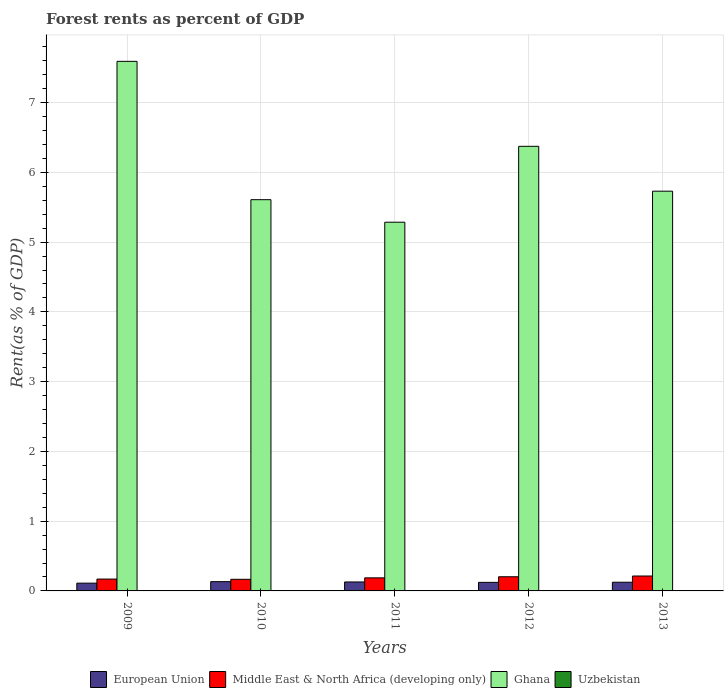How many different coloured bars are there?
Your answer should be very brief. 4. Are the number of bars per tick equal to the number of legend labels?
Make the answer very short. Yes. How many bars are there on the 2nd tick from the right?
Give a very brief answer. 4. What is the label of the 1st group of bars from the left?
Provide a short and direct response. 2009. In how many cases, is the number of bars for a given year not equal to the number of legend labels?
Your answer should be very brief. 0. What is the forest rent in Uzbekistan in 2010?
Your answer should be compact. 0. Across all years, what is the maximum forest rent in Ghana?
Provide a short and direct response. 7.59. Across all years, what is the minimum forest rent in European Union?
Offer a terse response. 0.11. What is the total forest rent in European Union in the graph?
Provide a short and direct response. 0.62. What is the difference between the forest rent in Ghana in 2009 and that in 2010?
Offer a terse response. 1.98. What is the difference between the forest rent in Uzbekistan in 2010 and the forest rent in European Union in 2012?
Provide a short and direct response. -0.12. What is the average forest rent in Uzbekistan per year?
Offer a very short reply. 0. In the year 2012, what is the difference between the forest rent in Uzbekistan and forest rent in Middle East & North Africa (developing only)?
Your answer should be compact. -0.2. In how many years, is the forest rent in Uzbekistan greater than 6.4 %?
Ensure brevity in your answer.  0. What is the ratio of the forest rent in Ghana in 2011 to that in 2012?
Provide a short and direct response. 0.83. Is the forest rent in Uzbekistan in 2010 less than that in 2011?
Your answer should be compact. Yes. Is the difference between the forest rent in Uzbekistan in 2010 and 2013 greater than the difference between the forest rent in Middle East & North Africa (developing only) in 2010 and 2013?
Keep it short and to the point. Yes. What is the difference between the highest and the second highest forest rent in European Union?
Keep it short and to the point. 0. What is the difference between the highest and the lowest forest rent in European Union?
Your answer should be compact. 0.02. In how many years, is the forest rent in Middle East & North Africa (developing only) greater than the average forest rent in Middle East & North Africa (developing only) taken over all years?
Provide a succinct answer. 2. What does the 2nd bar from the left in 2013 represents?
Ensure brevity in your answer.  Middle East & North Africa (developing only). Are all the bars in the graph horizontal?
Provide a succinct answer. No. What is the difference between two consecutive major ticks on the Y-axis?
Provide a succinct answer. 1. Does the graph contain any zero values?
Ensure brevity in your answer.  No. Where does the legend appear in the graph?
Ensure brevity in your answer.  Bottom center. What is the title of the graph?
Provide a succinct answer. Forest rents as percent of GDP. Does "Bhutan" appear as one of the legend labels in the graph?
Ensure brevity in your answer.  No. What is the label or title of the X-axis?
Keep it short and to the point. Years. What is the label or title of the Y-axis?
Give a very brief answer. Rent(as % of GDP). What is the Rent(as % of GDP) of European Union in 2009?
Keep it short and to the point. 0.11. What is the Rent(as % of GDP) in Middle East & North Africa (developing only) in 2009?
Give a very brief answer. 0.17. What is the Rent(as % of GDP) in Ghana in 2009?
Keep it short and to the point. 7.59. What is the Rent(as % of GDP) in Uzbekistan in 2009?
Your response must be concise. 0. What is the Rent(as % of GDP) of European Union in 2010?
Give a very brief answer. 0.13. What is the Rent(as % of GDP) of Middle East & North Africa (developing only) in 2010?
Your answer should be compact. 0.17. What is the Rent(as % of GDP) in Ghana in 2010?
Keep it short and to the point. 5.61. What is the Rent(as % of GDP) of Uzbekistan in 2010?
Offer a very short reply. 0. What is the Rent(as % of GDP) of European Union in 2011?
Offer a terse response. 0.13. What is the Rent(as % of GDP) of Middle East & North Africa (developing only) in 2011?
Your answer should be compact. 0.19. What is the Rent(as % of GDP) of Ghana in 2011?
Offer a terse response. 5.29. What is the Rent(as % of GDP) in Uzbekistan in 2011?
Provide a short and direct response. 0. What is the Rent(as % of GDP) of European Union in 2012?
Provide a short and direct response. 0.12. What is the Rent(as % of GDP) in Middle East & North Africa (developing only) in 2012?
Provide a short and direct response. 0.2. What is the Rent(as % of GDP) in Ghana in 2012?
Ensure brevity in your answer.  6.37. What is the Rent(as % of GDP) of Uzbekistan in 2012?
Provide a succinct answer. 0. What is the Rent(as % of GDP) in European Union in 2013?
Provide a short and direct response. 0.12. What is the Rent(as % of GDP) in Middle East & North Africa (developing only) in 2013?
Make the answer very short. 0.21. What is the Rent(as % of GDP) in Ghana in 2013?
Ensure brevity in your answer.  5.73. What is the Rent(as % of GDP) of Uzbekistan in 2013?
Make the answer very short. 0. Across all years, what is the maximum Rent(as % of GDP) of European Union?
Your answer should be very brief. 0.13. Across all years, what is the maximum Rent(as % of GDP) in Middle East & North Africa (developing only)?
Your answer should be very brief. 0.21. Across all years, what is the maximum Rent(as % of GDP) in Ghana?
Offer a terse response. 7.59. Across all years, what is the maximum Rent(as % of GDP) in Uzbekistan?
Ensure brevity in your answer.  0. Across all years, what is the minimum Rent(as % of GDP) of European Union?
Offer a very short reply. 0.11. Across all years, what is the minimum Rent(as % of GDP) in Middle East & North Africa (developing only)?
Give a very brief answer. 0.17. Across all years, what is the minimum Rent(as % of GDP) in Ghana?
Your answer should be compact. 5.29. Across all years, what is the minimum Rent(as % of GDP) in Uzbekistan?
Provide a short and direct response. 0. What is the total Rent(as % of GDP) of European Union in the graph?
Provide a short and direct response. 0.62. What is the total Rent(as % of GDP) in Middle East & North Africa (developing only) in the graph?
Offer a very short reply. 0.94. What is the total Rent(as % of GDP) of Ghana in the graph?
Give a very brief answer. 30.59. What is the total Rent(as % of GDP) of Uzbekistan in the graph?
Keep it short and to the point. 0.01. What is the difference between the Rent(as % of GDP) in European Union in 2009 and that in 2010?
Offer a very short reply. -0.02. What is the difference between the Rent(as % of GDP) in Middle East & North Africa (developing only) in 2009 and that in 2010?
Keep it short and to the point. 0. What is the difference between the Rent(as % of GDP) of Ghana in 2009 and that in 2010?
Offer a terse response. 1.98. What is the difference between the Rent(as % of GDP) in Uzbekistan in 2009 and that in 2010?
Make the answer very short. 0. What is the difference between the Rent(as % of GDP) of European Union in 2009 and that in 2011?
Your answer should be compact. -0.02. What is the difference between the Rent(as % of GDP) of Middle East & North Africa (developing only) in 2009 and that in 2011?
Your response must be concise. -0.02. What is the difference between the Rent(as % of GDP) in Ghana in 2009 and that in 2011?
Offer a very short reply. 2.31. What is the difference between the Rent(as % of GDP) in Uzbekistan in 2009 and that in 2011?
Your response must be concise. 0. What is the difference between the Rent(as % of GDP) in European Union in 2009 and that in 2012?
Make the answer very short. -0.01. What is the difference between the Rent(as % of GDP) in Middle East & North Africa (developing only) in 2009 and that in 2012?
Your answer should be very brief. -0.03. What is the difference between the Rent(as % of GDP) in Ghana in 2009 and that in 2012?
Make the answer very short. 1.22. What is the difference between the Rent(as % of GDP) in Uzbekistan in 2009 and that in 2012?
Your answer should be compact. 0. What is the difference between the Rent(as % of GDP) of European Union in 2009 and that in 2013?
Provide a succinct answer. -0.01. What is the difference between the Rent(as % of GDP) of Middle East & North Africa (developing only) in 2009 and that in 2013?
Ensure brevity in your answer.  -0.04. What is the difference between the Rent(as % of GDP) of Ghana in 2009 and that in 2013?
Your response must be concise. 1.86. What is the difference between the Rent(as % of GDP) in Uzbekistan in 2009 and that in 2013?
Ensure brevity in your answer.  0. What is the difference between the Rent(as % of GDP) of European Union in 2010 and that in 2011?
Offer a terse response. 0. What is the difference between the Rent(as % of GDP) in Middle East & North Africa (developing only) in 2010 and that in 2011?
Provide a succinct answer. -0.02. What is the difference between the Rent(as % of GDP) of Ghana in 2010 and that in 2011?
Offer a very short reply. 0.32. What is the difference between the Rent(as % of GDP) in Uzbekistan in 2010 and that in 2011?
Give a very brief answer. -0. What is the difference between the Rent(as % of GDP) of European Union in 2010 and that in 2012?
Ensure brevity in your answer.  0.01. What is the difference between the Rent(as % of GDP) of Middle East & North Africa (developing only) in 2010 and that in 2012?
Your answer should be compact. -0.04. What is the difference between the Rent(as % of GDP) in Ghana in 2010 and that in 2012?
Provide a short and direct response. -0.76. What is the difference between the Rent(as % of GDP) in Uzbekistan in 2010 and that in 2012?
Your answer should be compact. -0. What is the difference between the Rent(as % of GDP) of European Union in 2010 and that in 2013?
Your response must be concise. 0.01. What is the difference between the Rent(as % of GDP) of Middle East & North Africa (developing only) in 2010 and that in 2013?
Give a very brief answer. -0.05. What is the difference between the Rent(as % of GDP) of Ghana in 2010 and that in 2013?
Keep it short and to the point. -0.12. What is the difference between the Rent(as % of GDP) in European Union in 2011 and that in 2012?
Provide a succinct answer. 0.01. What is the difference between the Rent(as % of GDP) in Middle East & North Africa (developing only) in 2011 and that in 2012?
Ensure brevity in your answer.  -0.02. What is the difference between the Rent(as % of GDP) of Ghana in 2011 and that in 2012?
Provide a short and direct response. -1.09. What is the difference between the Rent(as % of GDP) in Uzbekistan in 2011 and that in 2012?
Provide a short and direct response. 0. What is the difference between the Rent(as % of GDP) in European Union in 2011 and that in 2013?
Make the answer very short. 0. What is the difference between the Rent(as % of GDP) of Middle East & North Africa (developing only) in 2011 and that in 2013?
Keep it short and to the point. -0.03. What is the difference between the Rent(as % of GDP) in Ghana in 2011 and that in 2013?
Your answer should be very brief. -0.44. What is the difference between the Rent(as % of GDP) in Uzbekistan in 2011 and that in 2013?
Your response must be concise. 0. What is the difference between the Rent(as % of GDP) of European Union in 2012 and that in 2013?
Your response must be concise. -0. What is the difference between the Rent(as % of GDP) of Middle East & North Africa (developing only) in 2012 and that in 2013?
Make the answer very short. -0.01. What is the difference between the Rent(as % of GDP) of Ghana in 2012 and that in 2013?
Your answer should be very brief. 0.64. What is the difference between the Rent(as % of GDP) of Uzbekistan in 2012 and that in 2013?
Offer a very short reply. 0. What is the difference between the Rent(as % of GDP) of European Union in 2009 and the Rent(as % of GDP) of Middle East & North Africa (developing only) in 2010?
Your answer should be compact. -0.06. What is the difference between the Rent(as % of GDP) of European Union in 2009 and the Rent(as % of GDP) of Ghana in 2010?
Give a very brief answer. -5.5. What is the difference between the Rent(as % of GDP) of European Union in 2009 and the Rent(as % of GDP) of Uzbekistan in 2010?
Offer a very short reply. 0.11. What is the difference between the Rent(as % of GDP) in Middle East & North Africa (developing only) in 2009 and the Rent(as % of GDP) in Ghana in 2010?
Provide a short and direct response. -5.44. What is the difference between the Rent(as % of GDP) of Middle East & North Africa (developing only) in 2009 and the Rent(as % of GDP) of Uzbekistan in 2010?
Provide a short and direct response. 0.17. What is the difference between the Rent(as % of GDP) of Ghana in 2009 and the Rent(as % of GDP) of Uzbekistan in 2010?
Your answer should be very brief. 7.59. What is the difference between the Rent(as % of GDP) of European Union in 2009 and the Rent(as % of GDP) of Middle East & North Africa (developing only) in 2011?
Your answer should be very brief. -0.08. What is the difference between the Rent(as % of GDP) in European Union in 2009 and the Rent(as % of GDP) in Ghana in 2011?
Offer a very short reply. -5.17. What is the difference between the Rent(as % of GDP) of European Union in 2009 and the Rent(as % of GDP) of Uzbekistan in 2011?
Your answer should be compact. 0.11. What is the difference between the Rent(as % of GDP) in Middle East & North Africa (developing only) in 2009 and the Rent(as % of GDP) in Ghana in 2011?
Provide a succinct answer. -5.12. What is the difference between the Rent(as % of GDP) of Middle East & North Africa (developing only) in 2009 and the Rent(as % of GDP) of Uzbekistan in 2011?
Make the answer very short. 0.17. What is the difference between the Rent(as % of GDP) of Ghana in 2009 and the Rent(as % of GDP) of Uzbekistan in 2011?
Ensure brevity in your answer.  7.59. What is the difference between the Rent(as % of GDP) in European Union in 2009 and the Rent(as % of GDP) in Middle East & North Africa (developing only) in 2012?
Give a very brief answer. -0.09. What is the difference between the Rent(as % of GDP) in European Union in 2009 and the Rent(as % of GDP) in Ghana in 2012?
Keep it short and to the point. -6.26. What is the difference between the Rent(as % of GDP) in European Union in 2009 and the Rent(as % of GDP) in Uzbekistan in 2012?
Provide a short and direct response. 0.11. What is the difference between the Rent(as % of GDP) of Middle East & North Africa (developing only) in 2009 and the Rent(as % of GDP) of Ghana in 2012?
Your answer should be very brief. -6.2. What is the difference between the Rent(as % of GDP) of Middle East & North Africa (developing only) in 2009 and the Rent(as % of GDP) of Uzbekistan in 2012?
Give a very brief answer. 0.17. What is the difference between the Rent(as % of GDP) in Ghana in 2009 and the Rent(as % of GDP) in Uzbekistan in 2012?
Ensure brevity in your answer.  7.59. What is the difference between the Rent(as % of GDP) of European Union in 2009 and the Rent(as % of GDP) of Middle East & North Africa (developing only) in 2013?
Provide a succinct answer. -0.1. What is the difference between the Rent(as % of GDP) of European Union in 2009 and the Rent(as % of GDP) of Ghana in 2013?
Offer a terse response. -5.62. What is the difference between the Rent(as % of GDP) of European Union in 2009 and the Rent(as % of GDP) of Uzbekistan in 2013?
Your answer should be compact. 0.11. What is the difference between the Rent(as % of GDP) of Middle East & North Africa (developing only) in 2009 and the Rent(as % of GDP) of Ghana in 2013?
Provide a short and direct response. -5.56. What is the difference between the Rent(as % of GDP) in Middle East & North Africa (developing only) in 2009 and the Rent(as % of GDP) in Uzbekistan in 2013?
Your response must be concise. 0.17. What is the difference between the Rent(as % of GDP) of Ghana in 2009 and the Rent(as % of GDP) of Uzbekistan in 2013?
Your response must be concise. 7.59. What is the difference between the Rent(as % of GDP) in European Union in 2010 and the Rent(as % of GDP) in Middle East & North Africa (developing only) in 2011?
Your answer should be compact. -0.05. What is the difference between the Rent(as % of GDP) in European Union in 2010 and the Rent(as % of GDP) in Ghana in 2011?
Make the answer very short. -5.15. What is the difference between the Rent(as % of GDP) in European Union in 2010 and the Rent(as % of GDP) in Uzbekistan in 2011?
Provide a short and direct response. 0.13. What is the difference between the Rent(as % of GDP) in Middle East & North Africa (developing only) in 2010 and the Rent(as % of GDP) in Ghana in 2011?
Your answer should be very brief. -5.12. What is the difference between the Rent(as % of GDP) in Middle East & North Africa (developing only) in 2010 and the Rent(as % of GDP) in Uzbekistan in 2011?
Give a very brief answer. 0.16. What is the difference between the Rent(as % of GDP) of Ghana in 2010 and the Rent(as % of GDP) of Uzbekistan in 2011?
Your answer should be very brief. 5.61. What is the difference between the Rent(as % of GDP) in European Union in 2010 and the Rent(as % of GDP) in Middle East & North Africa (developing only) in 2012?
Your answer should be compact. -0.07. What is the difference between the Rent(as % of GDP) of European Union in 2010 and the Rent(as % of GDP) of Ghana in 2012?
Provide a succinct answer. -6.24. What is the difference between the Rent(as % of GDP) in European Union in 2010 and the Rent(as % of GDP) in Uzbekistan in 2012?
Provide a succinct answer. 0.13. What is the difference between the Rent(as % of GDP) of Middle East & North Africa (developing only) in 2010 and the Rent(as % of GDP) of Ghana in 2012?
Your response must be concise. -6.21. What is the difference between the Rent(as % of GDP) in Middle East & North Africa (developing only) in 2010 and the Rent(as % of GDP) in Uzbekistan in 2012?
Keep it short and to the point. 0.16. What is the difference between the Rent(as % of GDP) in Ghana in 2010 and the Rent(as % of GDP) in Uzbekistan in 2012?
Give a very brief answer. 5.61. What is the difference between the Rent(as % of GDP) of European Union in 2010 and the Rent(as % of GDP) of Middle East & North Africa (developing only) in 2013?
Provide a short and direct response. -0.08. What is the difference between the Rent(as % of GDP) of European Union in 2010 and the Rent(as % of GDP) of Ghana in 2013?
Make the answer very short. -5.6. What is the difference between the Rent(as % of GDP) of European Union in 2010 and the Rent(as % of GDP) of Uzbekistan in 2013?
Your answer should be compact. 0.13. What is the difference between the Rent(as % of GDP) in Middle East & North Africa (developing only) in 2010 and the Rent(as % of GDP) in Ghana in 2013?
Offer a very short reply. -5.56. What is the difference between the Rent(as % of GDP) of Middle East & North Africa (developing only) in 2010 and the Rent(as % of GDP) of Uzbekistan in 2013?
Make the answer very short. 0.16. What is the difference between the Rent(as % of GDP) of Ghana in 2010 and the Rent(as % of GDP) of Uzbekistan in 2013?
Offer a terse response. 5.61. What is the difference between the Rent(as % of GDP) of European Union in 2011 and the Rent(as % of GDP) of Middle East & North Africa (developing only) in 2012?
Ensure brevity in your answer.  -0.07. What is the difference between the Rent(as % of GDP) in European Union in 2011 and the Rent(as % of GDP) in Ghana in 2012?
Your answer should be compact. -6.24. What is the difference between the Rent(as % of GDP) of European Union in 2011 and the Rent(as % of GDP) of Uzbekistan in 2012?
Provide a succinct answer. 0.13. What is the difference between the Rent(as % of GDP) in Middle East & North Africa (developing only) in 2011 and the Rent(as % of GDP) in Ghana in 2012?
Keep it short and to the point. -6.19. What is the difference between the Rent(as % of GDP) of Middle East & North Africa (developing only) in 2011 and the Rent(as % of GDP) of Uzbekistan in 2012?
Provide a short and direct response. 0.18. What is the difference between the Rent(as % of GDP) in Ghana in 2011 and the Rent(as % of GDP) in Uzbekistan in 2012?
Offer a very short reply. 5.28. What is the difference between the Rent(as % of GDP) of European Union in 2011 and the Rent(as % of GDP) of Middle East & North Africa (developing only) in 2013?
Keep it short and to the point. -0.09. What is the difference between the Rent(as % of GDP) in European Union in 2011 and the Rent(as % of GDP) in Ghana in 2013?
Your answer should be compact. -5.6. What is the difference between the Rent(as % of GDP) in European Union in 2011 and the Rent(as % of GDP) in Uzbekistan in 2013?
Offer a terse response. 0.13. What is the difference between the Rent(as % of GDP) in Middle East & North Africa (developing only) in 2011 and the Rent(as % of GDP) in Ghana in 2013?
Make the answer very short. -5.54. What is the difference between the Rent(as % of GDP) in Middle East & North Africa (developing only) in 2011 and the Rent(as % of GDP) in Uzbekistan in 2013?
Your response must be concise. 0.19. What is the difference between the Rent(as % of GDP) in Ghana in 2011 and the Rent(as % of GDP) in Uzbekistan in 2013?
Provide a short and direct response. 5.28. What is the difference between the Rent(as % of GDP) of European Union in 2012 and the Rent(as % of GDP) of Middle East & North Africa (developing only) in 2013?
Your answer should be compact. -0.09. What is the difference between the Rent(as % of GDP) of European Union in 2012 and the Rent(as % of GDP) of Ghana in 2013?
Provide a short and direct response. -5.61. What is the difference between the Rent(as % of GDP) in European Union in 2012 and the Rent(as % of GDP) in Uzbekistan in 2013?
Your answer should be very brief. 0.12. What is the difference between the Rent(as % of GDP) of Middle East & North Africa (developing only) in 2012 and the Rent(as % of GDP) of Ghana in 2013?
Give a very brief answer. -5.53. What is the difference between the Rent(as % of GDP) in Middle East & North Africa (developing only) in 2012 and the Rent(as % of GDP) in Uzbekistan in 2013?
Make the answer very short. 0.2. What is the difference between the Rent(as % of GDP) in Ghana in 2012 and the Rent(as % of GDP) in Uzbekistan in 2013?
Your answer should be compact. 6.37. What is the average Rent(as % of GDP) of European Union per year?
Your answer should be very brief. 0.12. What is the average Rent(as % of GDP) in Middle East & North Africa (developing only) per year?
Ensure brevity in your answer.  0.19. What is the average Rent(as % of GDP) in Ghana per year?
Provide a succinct answer. 6.12. What is the average Rent(as % of GDP) of Uzbekistan per year?
Your answer should be very brief. 0. In the year 2009, what is the difference between the Rent(as % of GDP) in European Union and Rent(as % of GDP) in Middle East & North Africa (developing only)?
Make the answer very short. -0.06. In the year 2009, what is the difference between the Rent(as % of GDP) in European Union and Rent(as % of GDP) in Ghana?
Offer a terse response. -7.48. In the year 2009, what is the difference between the Rent(as % of GDP) of European Union and Rent(as % of GDP) of Uzbekistan?
Offer a very short reply. 0.11. In the year 2009, what is the difference between the Rent(as % of GDP) in Middle East & North Africa (developing only) and Rent(as % of GDP) in Ghana?
Keep it short and to the point. -7.42. In the year 2009, what is the difference between the Rent(as % of GDP) of Middle East & North Africa (developing only) and Rent(as % of GDP) of Uzbekistan?
Your answer should be very brief. 0.17. In the year 2009, what is the difference between the Rent(as % of GDP) in Ghana and Rent(as % of GDP) in Uzbekistan?
Your response must be concise. 7.59. In the year 2010, what is the difference between the Rent(as % of GDP) of European Union and Rent(as % of GDP) of Middle East & North Africa (developing only)?
Make the answer very short. -0.03. In the year 2010, what is the difference between the Rent(as % of GDP) of European Union and Rent(as % of GDP) of Ghana?
Keep it short and to the point. -5.48. In the year 2010, what is the difference between the Rent(as % of GDP) of European Union and Rent(as % of GDP) of Uzbekistan?
Offer a terse response. 0.13. In the year 2010, what is the difference between the Rent(as % of GDP) of Middle East & North Africa (developing only) and Rent(as % of GDP) of Ghana?
Your answer should be very brief. -5.44. In the year 2010, what is the difference between the Rent(as % of GDP) of Middle East & North Africa (developing only) and Rent(as % of GDP) of Uzbekistan?
Your answer should be very brief. 0.16. In the year 2010, what is the difference between the Rent(as % of GDP) in Ghana and Rent(as % of GDP) in Uzbekistan?
Your response must be concise. 5.61. In the year 2011, what is the difference between the Rent(as % of GDP) in European Union and Rent(as % of GDP) in Middle East & North Africa (developing only)?
Your answer should be very brief. -0.06. In the year 2011, what is the difference between the Rent(as % of GDP) in European Union and Rent(as % of GDP) in Ghana?
Make the answer very short. -5.16. In the year 2011, what is the difference between the Rent(as % of GDP) of European Union and Rent(as % of GDP) of Uzbekistan?
Provide a short and direct response. 0.13. In the year 2011, what is the difference between the Rent(as % of GDP) in Middle East & North Africa (developing only) and Rent(as % of GDP) in Ghana?
Give a very brief answer. -5.1. In the year 2011, what is the difference between the Rent(as % of GDP) of Middle East & North Africa (developing only) and Rent(as % of GDP) of Uzbekistan?
Your response must be concise. 0.18. In the year 2011, what is the difference between the Rent(as % of GDP) of Ghana and Rent(as % of GDP) of Uzbekistan?
Provide a succinct answer. 5.28. In the year 2012, what is the difference between the Rent(as % of GDP) in European Union and Rent(as % of GDP) in Middle East & North Africa (developing only)?
Provide a succinct answer. -0.08. In the year 2012, what is the difference between the Rent(as % of GDP) in European Union and Rent(as % of GDP) in Ghana?
Your response must be concise. -6.25. In the year 2012, what is the difference between the Rent(as % of GDP) in European Union and Rent(as % of GDP) in Uzbekistan?
Give a very brief answer. 0.12. In the year 2012, what is the difference between the Rent(as % of GDP) of Middle East & North Africa (developing only) and Rent(as % of GDP) of Ghana?
Give a very brief answer. -6.17. In the year 2012, what is the difference between the Rent(as % of GDP) of Middle East & North Africa (developing only) and Rent(as % of GDP) of Uzbekistan?
Offer a terse response. 0.2. In the year 2012, what is the difference between the Rent(as % of GDP) of Ghana and Rent(as % of GDP) of Uzbekistan?
Your answer should be very brief. 6.37. In the year 2013, what is the difference between the Rent(as % of GDP) in European Union and Rent(as % of GDP) in Middle East & North Africa (developing only)?
Ensure brevity in your answer.  -0.09. In the year 2013, what is the difference between the Rent(as % of GDP) in European Union and Rent(as % of GDP) in Ghana?
Provide a short and direct response. -5.61. In the year 2013, what is the difference between the Rent(as % of GDP) in European Union and Rent(as % of GDP) in Uzbekistan?
Offer a terse response. 0.12. In the year 2013, what is the difference between the Rent(as % of GDP) of Middle East & North Africa (developing only) and Rent(as % of GDP) of Ghana?
Your answer should be compact. -5.52. In the year 2013, what is the difference between the Rent(as % of GDP) in Middle East & North Africa (developing only) and Rent(as % of GDP) in Uzbekistan?
Give a very brief answer. 0.21. In the year 2013, what is the difference between the Rent(as % of GDP) of Ghana and Rent(as % of GDP) of Uzbekistan?
Ensure brevity in your answer.  5.73. What is the ratio of the Rent(as % of GDP) in European Union in 2009 to that in 2010?
Ensure brevity in your answer.  0.84. What is the ratio of the Rent(as % of GDP) in Middle East & North Africa (developing only) in 2009 to that in 2010?
Make the answer very short. 1.02. What is the ratio of the Rent(as % of GDP) in Ghana in 2009 to that in 2010?
Ensure brevity in your answer.  1.35. What is the ratio of the Rent(as % of GDP) of Uzbekistan in 2009 to that in 2010?
Offer a terse response. 1.52. What is the ratio of the Rent(as % of GDP) in European Union in 2009 to that in 2011?
Provide a short and direct response. 0.87. What is the ratio of the Rent(as % of GDP) of Middle East & North Africa (developing only) in 2009 to that in 2011?
Provide a short and direct response. 0.91. What is the ratio of the Rent(as % of GDP) of Ghana in 2009 to that in 2011?
Offer a terse response. 1.44. What is the ratio of the Rent(as % of GDP) of Uzbekistan in 2009 to that in 2011?
Offer a terse response. 1.23. What is the ratio of the Rent(as % of GDP) in European Union in 2009 to that in 2012?
Ensure brevity in your answer.  0.91. What is the ratio of the Rent(as % of GDP) in Middle East & North Africa (developing only) in 2009 to that in 2012?
Your answer should be very brief. 0.84. What is the ratio of the Rent(as % of GDP) of Ghana in 2009 to that in 2012?
Your answer should be very brief. 1.19. What is the ratio of the Rent(as % of GDP) in Uzbekistan in 2009 to that in 2012?
Offer a terse response. 1.44. What is the ratio of the Rent(as % of GDP) of European Union in 2009 to that in 2013?
Offer a terse response. 0.89. What is the ratio of the Rent(as % of GDP) of Middle East & North Africa (developing only) in 2009 to that in 2013?
Offer a terse response. 0.79. What is the ratio of the Rent(as % of GDP) in Ghana in 2009 to that in 2013?
Your answer should be very brief. 1.32. What is the ratio of the Rent(as % of GDP) in Uzbekistan in 2009 to that in 2013?
Offer a very short reply. 1.51. What is the ratio of the Rent(as % of GDP) in European Union in 2010 to that in 2011?
Your response must be concise. 1.03. What is the ratio of the Rent(as % of GDP) of Middle East & North Africa (developing only) in 2010 to that in 2011?
Give a very brief answer. 0.89. What is the ratio of the Rent(as % of GDP) in Ghana in 2010 to that in 2011?
Provide a short and direct response. 1.06. What is the ratio of the Rent(as % of GDP) in Uzbekistan in 2010 to that in 2011?
Keep it short and to the point. 0.81. What is the ratio of the Rent(as % of GDP) in European Union in 2010 to that in 2012?
Your response must be concise. 1.08. What is the ratio of the Rent(as % of GDP) of Middle East & North Africa (developing only) in 2010 to that in 2012?
Provide a short and direct response. 0.82. What is the ratio of the Rent(as % of GDP) of Ghana in 2010 to that in 2012?
Your answer should be very brief. 0.88. What is the ratio of the Rent(as % of GDP) of Uzbekistan in 2010 to that in 2012?
Keep it short and to the point. 0.94. What is the ratio of the Rent(as % of GDP) of European Union in 2010 to that in 2013?
Provide a short and direct response. 1.07. What is the ratio of the Rent(as % of GDP) in Middle East & North Africa (developing only) in 2010 to that in 2013?
Provide a short and direct response. 0.78. What is the ratio of the Rent(as % of GDP) in Ghana in 2010 to that in 2013?
Keep it short and to the point. 0.98. What is the ratio of the Rent(as % of GDP) of European Union in 2011 to that in 2012?
Offer a very short reply. 1.05. What is the ratio of the Rent(as % of GDP) in Middle East & North Africa (developing only) in 2011 to that in 2012?
Your answer should be compact. 0.92. What is the ratio of the Rent(as % of GDP) of Ghana in 2011 to that in 2012?
Ensure brevity in your answer.  0.83. What is the ratio of the Rent(as % of GDP) in Uzbekistan in 2011 to that in 2012?
Give a very brief answer. 1.17. What is the ratio of the Rent(as % of GDP) of European Union in 2011 to that in 2013?
Make the answer very short. 1.03. What is the ratio of the Rent(as % of GDP) in Middle East & North Africa (developing only) in 2011 to that in 2013?
Provide a short and direct response. 0.88. What is the ratio of the Rent(as % of GDP) of Ghana in 2011 to that in 2013?
Your response must be concise. 0.92. What is the ratio of the Rent(as % of GDP) in Uzbekistan in 2011 to that in 2013?
Give a very brief answer. 1.23. What is the ratio of the Rent(as % of GDP) of European Union in 2012 to that in 2013?
Offer a very short reply. 0.98. What is the ratio of the Rent(as % of GDP) in Middle East & North Africa (developing only) in 2012 to that in 2013?
Offer a very short reply. 0.95. What is the ratio of the Rent(as % of GDP) in Ghana in 2012 to that in 2013?
Your response must be concise. 1.11. What is the ratio of the Rent(as % of GDP) in Uzbekistan in 2012 to that in 2013?
Offer a very short reply. 1.05. What is the difference between the highest and the second highest Rent(as % of GDP) in European Union?
Your response must be concise. 0. What is the difference between the highest and the second highest Rent(as % of GDP) in Middle East & North Africa (developing only)?
Keep it short and to the point. 0.01. What is the difference between the highest and the second highest Rent(as % of GDP) of Ghana?
Your answer should be compact. 1.22. What is the difference between the highest and the second highest Rent(as % of GDP) in Uzbekistan?
Offer a very short reply. 0. What is the difference between the highest and the lowest Rent(as % of GDP) of European Union?
Ensure brevity in your answer.  0.02. What is the difference between the highest and the lowest Rent(as % of GDP) of Middle East & North Africa (developing only)?
Your response must be concise. 0.05. What is the difference between the highest and the lowest Rent(as % of GDP) of Ghana?
Offer a very short reply. 2.31. What is the difference between the highest and the lowest Rent(as % of GDP) in Uzbekistan?
Your answer should be very brief. 0. 